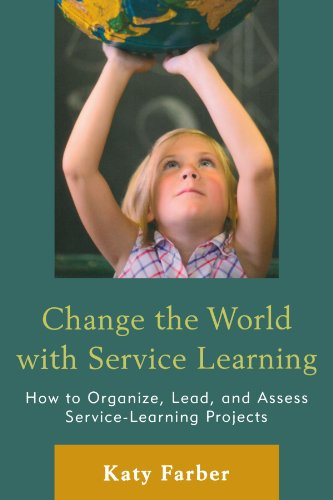What educational levels is this book targeted at? The book 'Change the World with Service Learning' is primarily targeted at educators, school administrators, and potentially students at higher educational levels who are looking to implement and manage service-learning projects. 